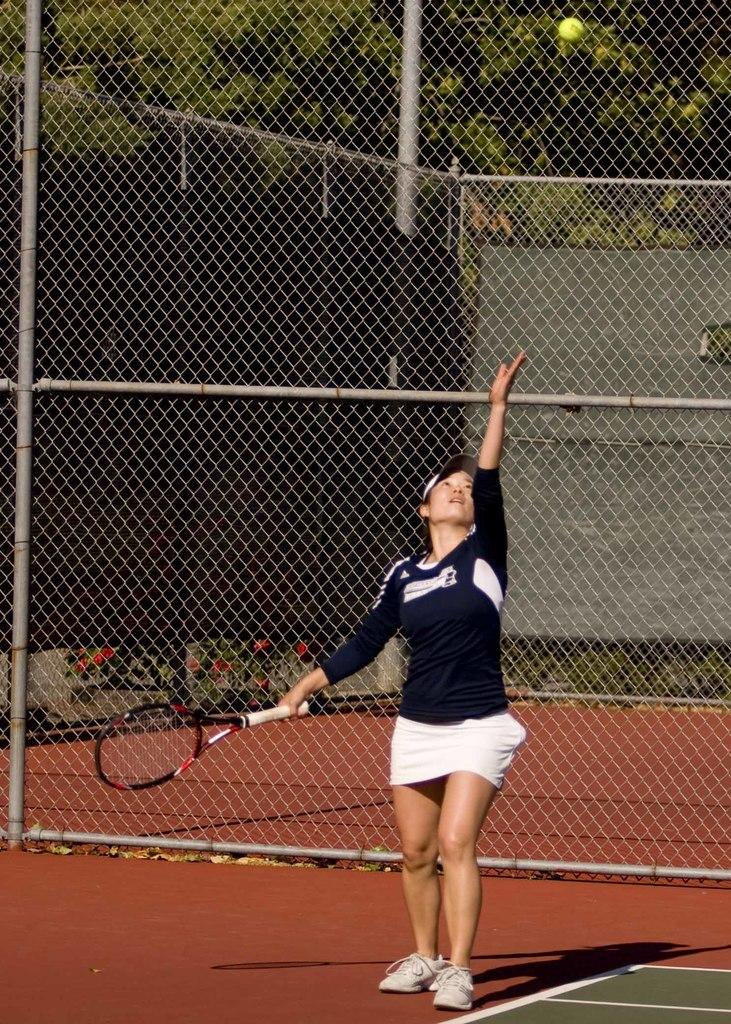Who is present in the image? There is a woman in the image. What is the woman doing in the image? The woman is standing in the image. What object is the woman holding? The woman is holding a racket in the image. What other item related to the sport can be seen in the image? There is a tennis ball in the image. What type of discussion is taking place between the woman and the crate in the image? There is no crate present in the image, and therefore no discussion can be observed. 